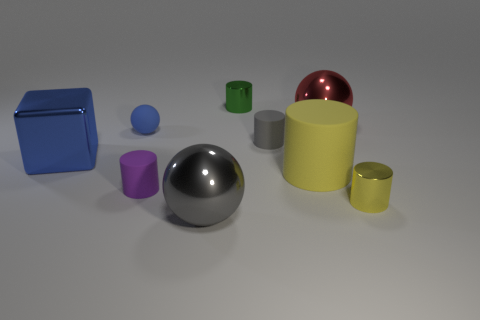Subtract all gray spheres. How many yellow cylinders are left? 2 Subtract all green cylinders. How many cylinders are left? 4 Subtract 1 cylinders. How many cylinders are left? 4 Subtract all large spheres. How many spheres are left? 1 Add 1 yellow shiny balls. How many objects exist? 10 Subtract all gray cylinders. Subtract all red spheres. How many cylinders are left? 4 Subtract all cylinders. How many objects are left? 4 Add 5 tiny purple cylinders. How many tiny purple cylinders are left? 6 Add 8 large matte cylinders. How many large matte cylinders exist? 9 Subtract 0 cyan balls. How many objects are left? 9 